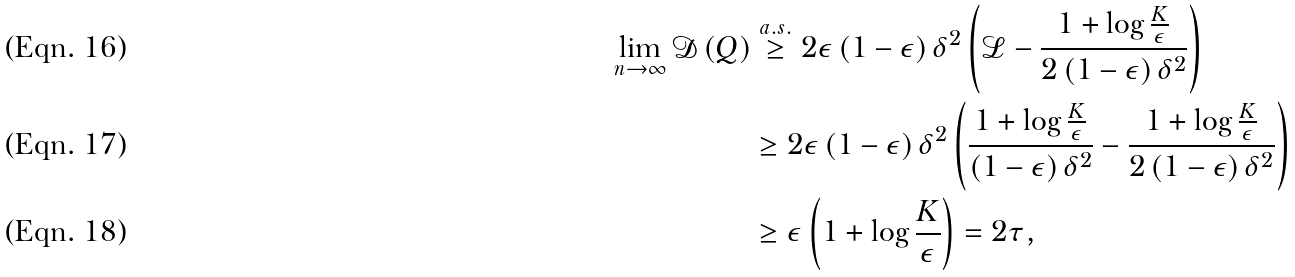<formula> <loc_0><loc_0><loc_500><loc_500>\lim _ { n \rightarrow \infty } \mathcal { D } \left ( Q \right ) & \stackrel { a . s . } { \geq } 2 \epsilon \left ( 1 - \epsilon \right ) \delta ^ { 2 } \left ( \mathcal { L } - \frac { 1 + \log \frac { K } { \epsilon } } { 2 \left ( 1 - \epsilon \right ) \delta ^ { 2 } } \right ) \\ & \geq 2 \epsilon \left ( 1 - \epsilon \right ) \delta ^ { 2 } \left ( \frac { 1 + \log \frac { K } { \epsilon } } { \left ( 1 - \epsilon \right ) \delta ^ { 2 } } - \frac { 1 + \log \frac { K } { \epsilon } } { 2 \left ( 1 - \epsilon \right ) \delta ^ { 2 } } \right ) \\ & \geq \epsilon \left ( 1 + \log \frac { K } { \epsilon } \right ) = 2 \tau ,</formula> 